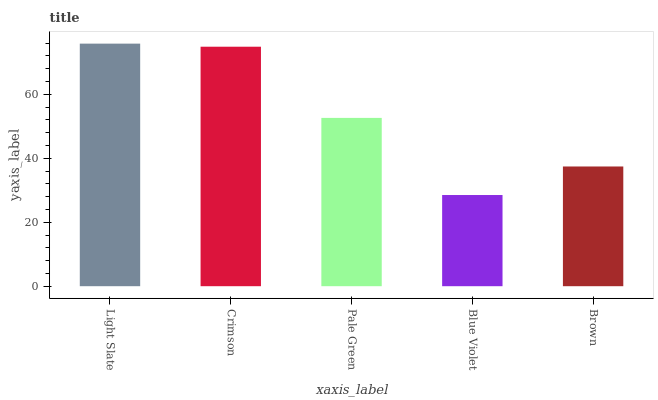Is Blue Violet the minimum?
Answer yes or no. Yes. Is Light Slate the maximum?
Answer yes or no. Yes. Is Crimson the minimum?
Answer yes or no. No. Is Crimson the maximum?
Answer yes or no. No. Is Light Slate greater than Crimson?
Answer yes or no. Yes. Is Crimson less than Light Slate?
Answer yes or no. Yes. Is Crimson greater than Light Slate?
Answer yes or no. No. Is Light Slate less than Crimson?
Answer yes or no. No. Is Pale Green the high median?
Answer yes or no. Yes. Is Pale Green the low median?
Answer yes or no. Yes. Is Brown the high median?
Answer yes or no. No. Is Light Slate the low median?
Answer yes or no. No. 